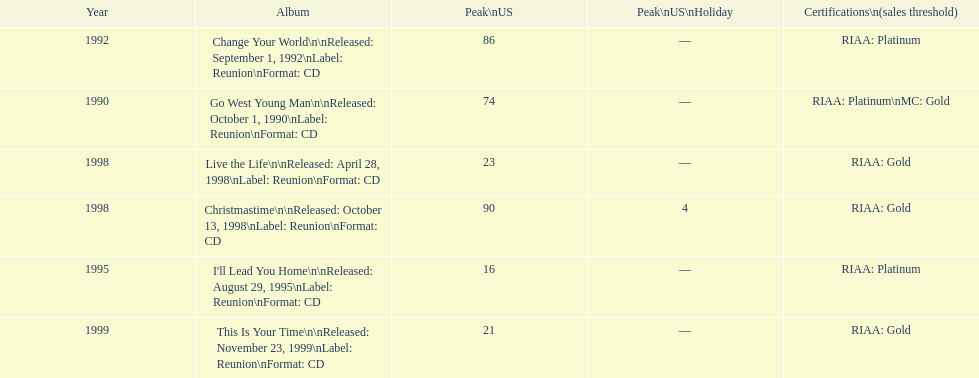How many album entries are there? 6. 